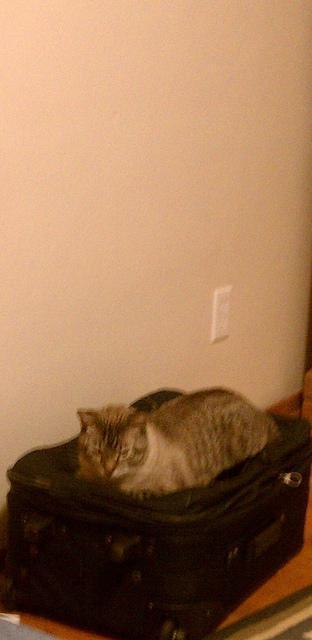How many electrical outlets can you see?
Give a very brief answer. 1. How many bears are there?
Give a very brief answer. 0. 